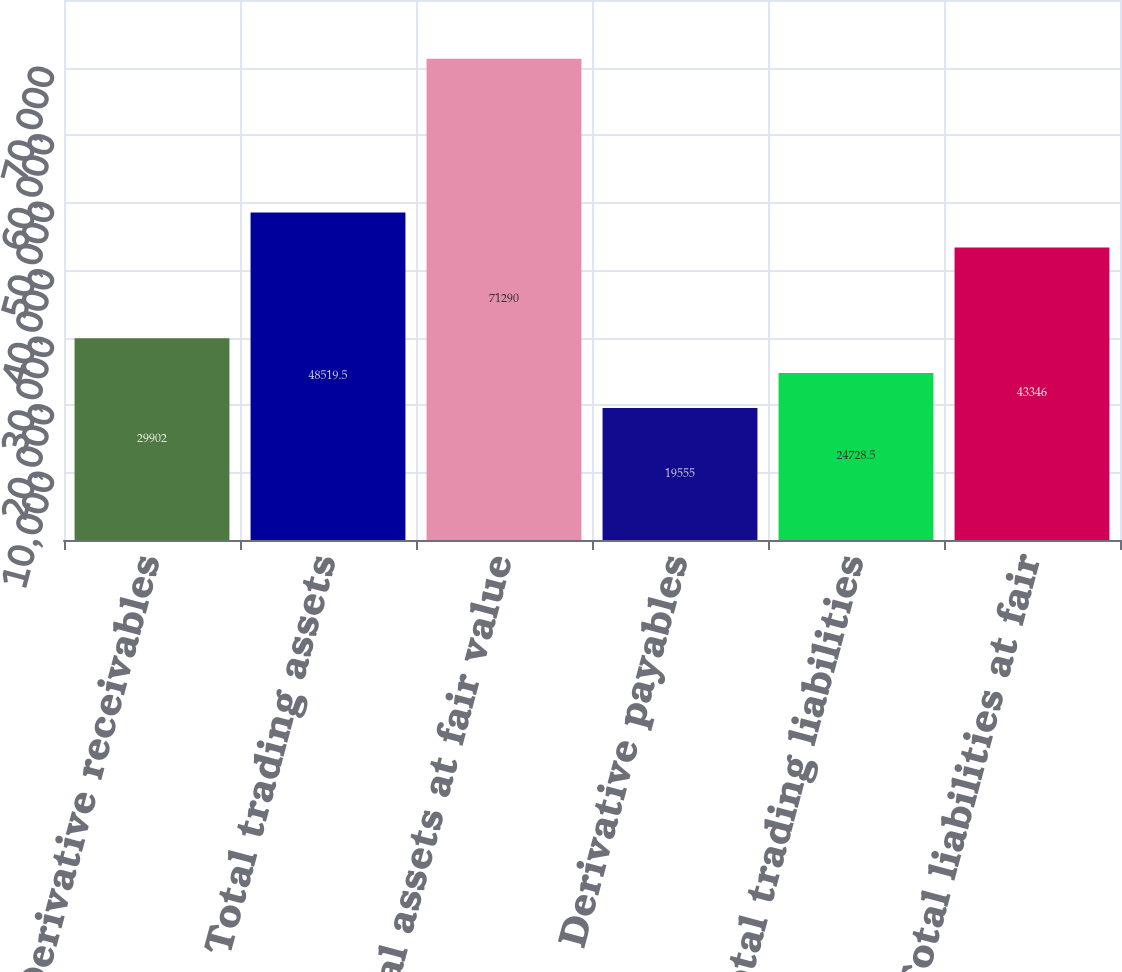Convert chart to OTSL. <chart><loc_0><loc_0><loc_500><loc_500><bar_chart><fcel>Derivative receivables<fcel>Total trading assets<fcel>Total assets at fair value<fcel>Derivative payables<fcel>Total trading liabilities<fcel>Total liabilities at fair<nl><fcel>29902<fcel>48519.5<fcel>71290<fcel>19555<fcel>24728.5<fcel>43346<nl></chart> 